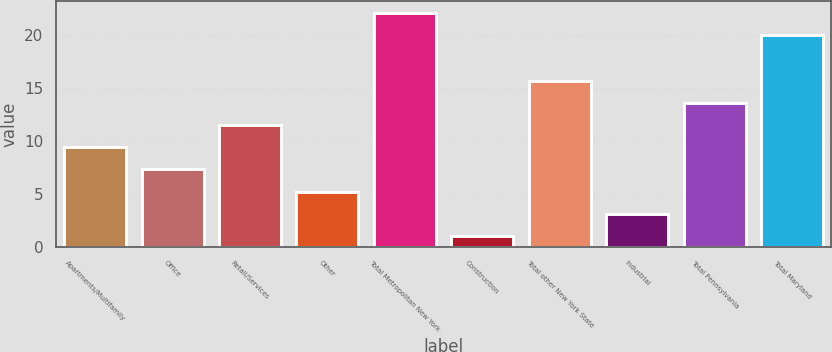Convert chart to OTSL. <chart><loc_0><loc_0><loc_500><loc_500><bar_chart><fcel>Apartments/Multifamily<fcel>Office<fcel>Retail/Services<fcel>Other<fcel>Total Metropolitan New York<fcel>Construction<fcel>Total other New York State<fcel>Industrial<fcel>Total Pennsylvania<fcel>Total Maryland<nl><fcel>9.4<fcel>7.3<fcel>11.5<fcel>5.2<fcel>22.1<fcel>1<fcel>15.7<fcel>3.1<fcel>13.6<fcel>20<nl></chart> 